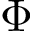<formula> <loc_0><loc_0><loc_500><loc_500>\Phi</formula> 